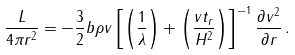Convert formula to latex. <formula><loc_0><loc_0><loc_500><loc_500>\frac { L } { 4 \pi r ^ { 2 } } = - \frac { 3 } { 2 } b \rho v \left [ \left ( \frac { 1 } { \lambda } \right ) + \left ( \frac { v t _ { r } } { H ^ { 2 } } \right ) \right ] ^ { - 1 } \frac { \partial v ^ { 2 } } { \partial r } \, .</formula> 